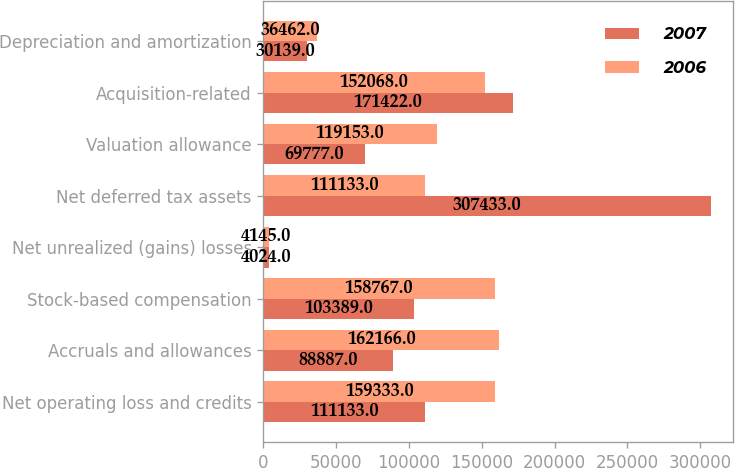Convert chart. <chart><loc_0><loc_0><loc_500><loc_500><stacked_bar_chart><ecel><fcel>Net operating loss and credits<fcel>Accruals and allowances<fcel>Stock-based compensation<fcel>Net unrealized (gains) losses<fcel>Net deferred tax assets<fcel>Valuation allowance<fcel>Acquisition-related<fcel>Depreciation and amortization<nl><fcel>2007<fcel>111133<fcel>88887<fcel>103389<fcel>4024<fcel>307433<fcel>69777<fcel>171422<fcel>30139<nl><fcel>2006<fcel>159333<fcel>162166<fcel>158767<fcel>4145<fcel>111133<fcel>119153<fcel>152068<fcel>36462<nl></chart> 